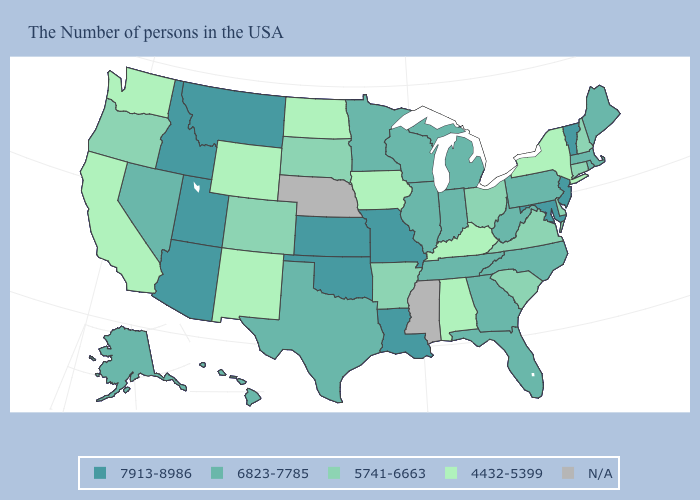Is the legend a continuous bar?
Answer briefly. No. Among the states that border Nebraska , which have the highest value?
Keep it brief. Missouri, Kansas. Name the states that have a value in the range 4432-5399?
Keep it brief. New York, Kentucky, Alabama, Iowa, North Dakota, Wyoming, New Mexico, California, Washington. Name the states that have a value in the range N/A?
Be succinct. Mississippi, Nebraska. Name the states that have a value in the range N/A?
Short answer required. Mississippi, Nebraska. Name the states that have a value in the range 6823-7785?
Give a very brief answer. Maine, Massachusetts, Rhode Island, Pennsylvania, North Carolina, West Virginia, Florida, Georgia, Michigan, Indiana, Tennessee, Wisconsin, Illinois, Minnesota, Texas, Nevada, Alaska, Hawaii. Is the legend a continuous bar?
Be succinct. No. What is the lowest value in the USA?
Short answer required. 4432-5399. Name the states that have a value in the range 6823-7785?
Short answer required. Maine, Massachusetts, Rhode Island, Pennsylvania, North Carolina, West Virginia, Florida, Georgia, Michigan, Indiana, Tennessee, Wisconsin, Illinois, Minnesota, Texas, Nevada, Alaska, Hawaii. What is the value of Wisconsin?
Answer briefly. 6823-7785. Name the states that have a value in the range 6823-7785?
Give a very brief answer. Maine, Massachusetts, Rhode Island, Pennsylvania, North Carolina, West Virginia, Florida, Georgia, Michigan, Indiana, Tennessee, Wisconsin, Illinois, Minnesota, Texas, Nevada, Alaska, Hawaii. What is the lowest value in the USA?
Give a very brief answer. 4432-5399. What is the value of Utah?
Answer briefly. 7913-8986. Is the legend a continuous bar?
Answer briefly. No. 